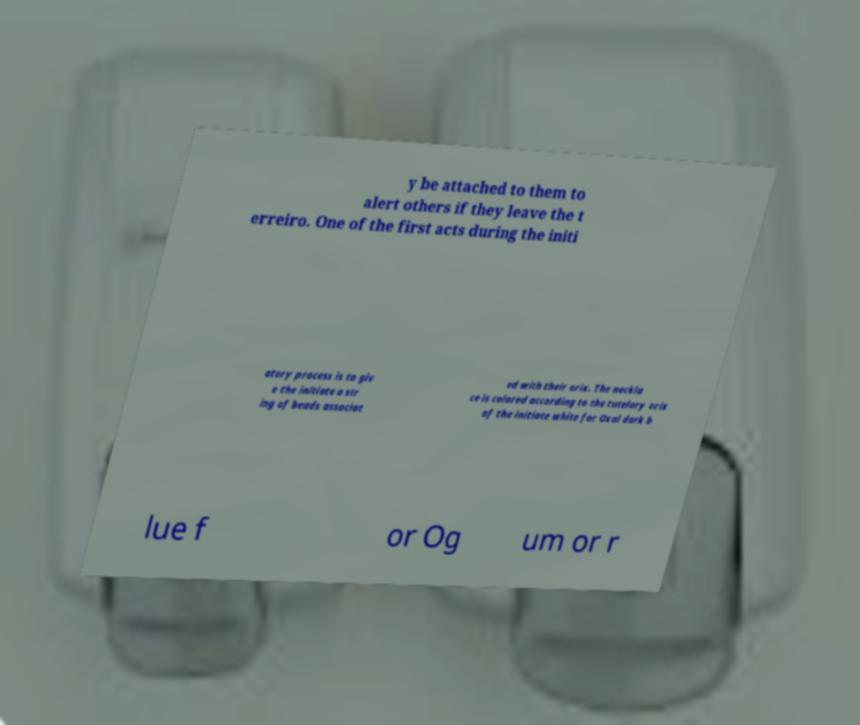There's text embedded in this image that I need extracted. Can you transcribe it verbatim? y be attached to them to alert others if they leave the t erreiro. One of the first acts during the initi atory process is to giv e the initiate a str ing of beads associat ed with their orix. The neckla ce is colored according to the tutelary orix of the initiate white for Oxal dark b lue f or Og um or r 